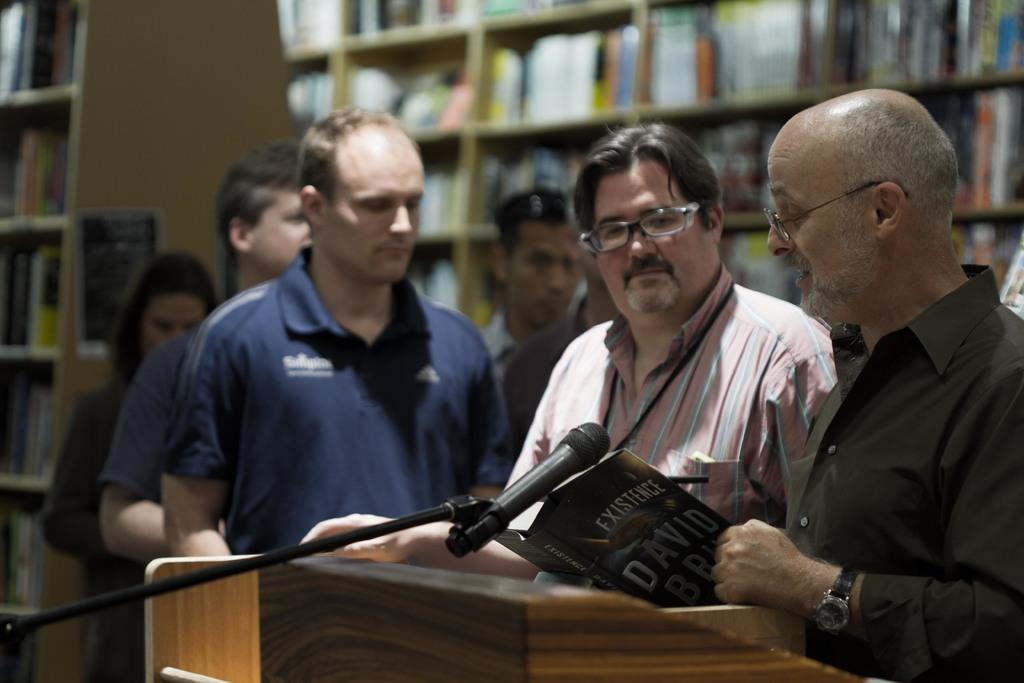<image>
Present a compact description of the photo's key features. A group of men are speaking at a podium and reading from a book called Existence. 